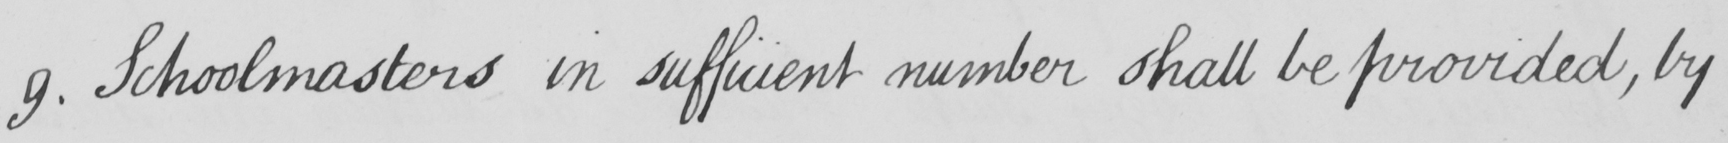Please provide the text content of this handwritten line. 9 . Schoolmasters in sufficient number shall be provided , by 